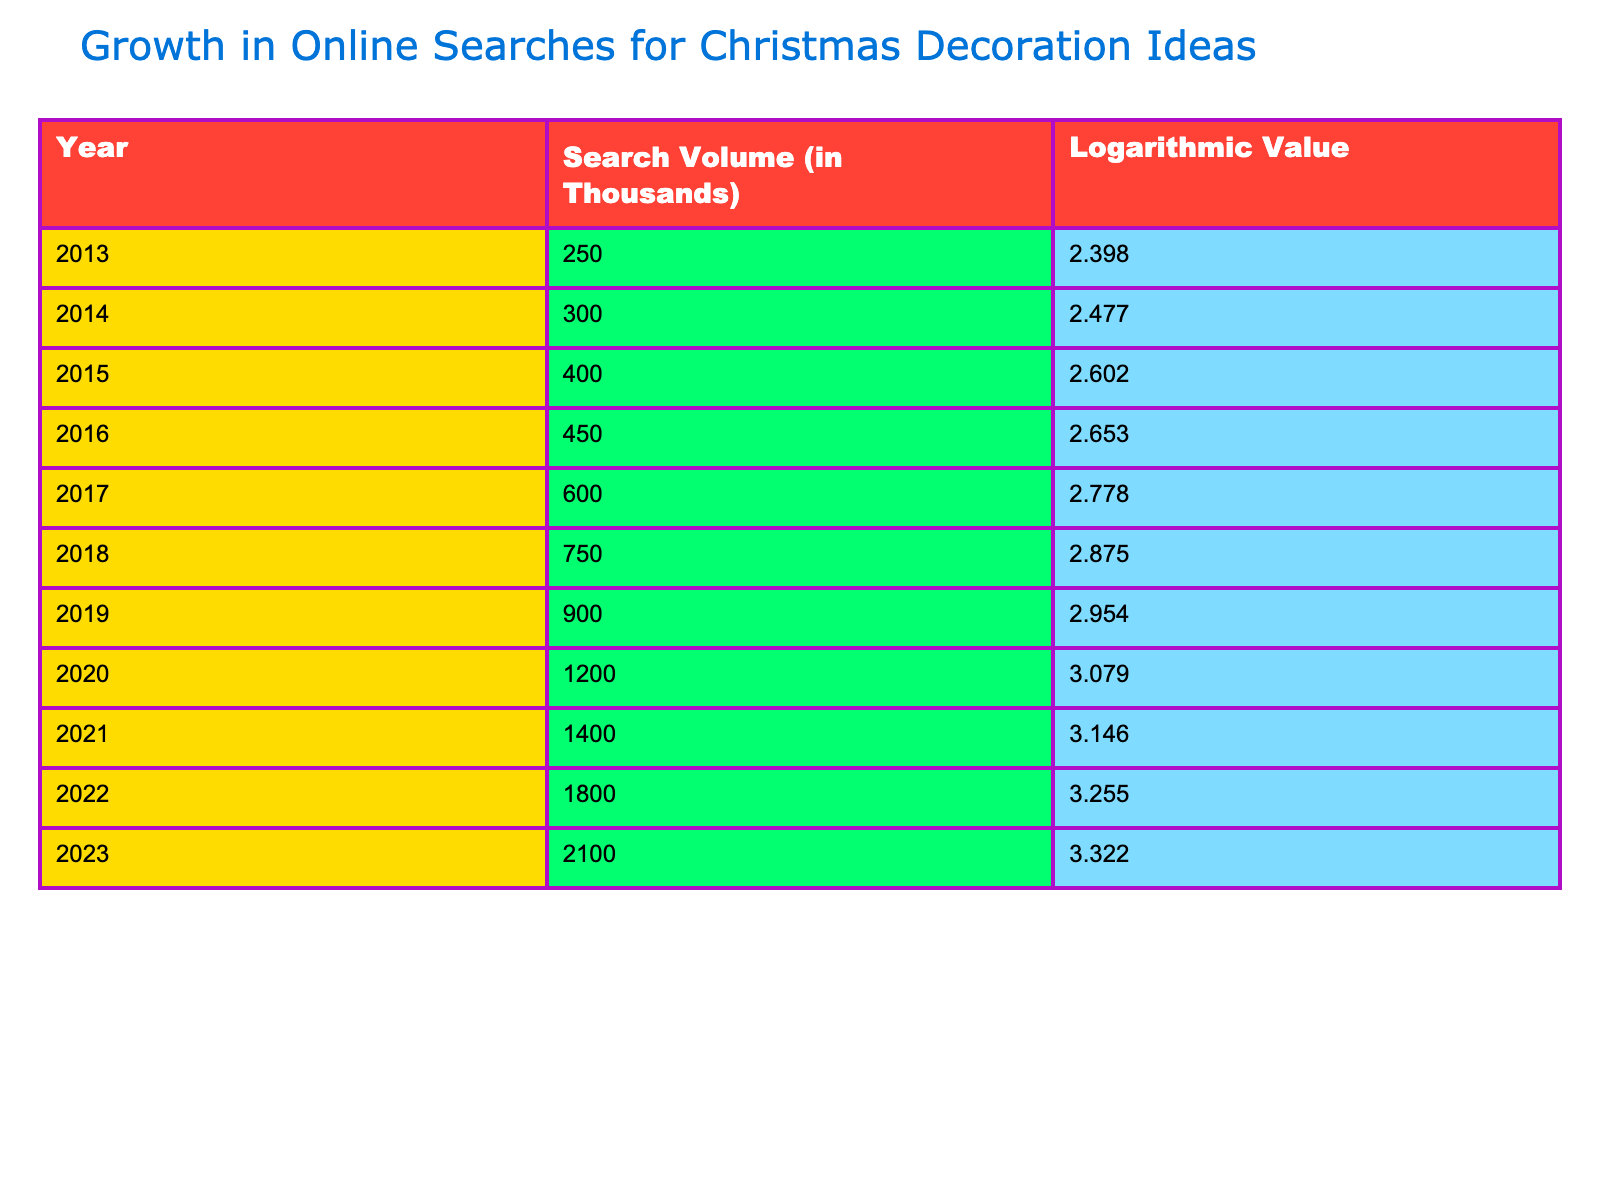What was the search volume for Christmas decoration ideas in 2013? The table shows that in 2013, the search volume was 250,000, as this value is explicitly listed in the row for that year.
Answer: 250 What was the logarithmic value for the year with the highest search volume? By reviewing the table, the year with the highest search volume is 2023, which has a logarithmic value of 3.322.
Answer: 3.322 What is the difference in search volume between 2015 and 2022? The search volume in 2015 is 400,000 and in 2022 is 1,800,000. The difference is calculated as 1,800 - 400 = 1,400,000.
Answer: 1400 Is the logarithmic value for 2021 greater than that for 2016? The logarithmic value for 2021 is 3.146, and for 2016 it is 2.653. Since 3.146 is greater than 2.653, the statement is true.
Answer: Yes What is the average search volume for the years 2014 through 2016? The search volumes for 2014, 2015, and 2016 are 300, 400, and 450 respectively. Summing these gives 300 + 400 + 450 = 1150. Dividing by 3 gives an average of 1150 / 3 = approximately 383.33 or about 383, when rounded.
Answer: 383 In which year did the search volume experience the greatest increase compared to the previous year? Comparing the differences from each year to the previous, the increase from 2019 (900) to 2020 (1,200) is 300, which is greater than any other annual change.
Answer: 2020 What trend do you see in the logarithmic values over the years provided? The logarithmic values consistently increase from 2.398 in 2013 to 3.322 in 2023, indicating a steady growth in online searches for Christmas decoration ideas over the decade.
Answer: Steady increase What two years had a search volume greater than 1 million? By checking each year’s search volume, 2020 (1,200) and 2021 (1,400) are the only years that exceed 1 million. Therefore, they are the years in question.
Answer: 2020 and 2021 